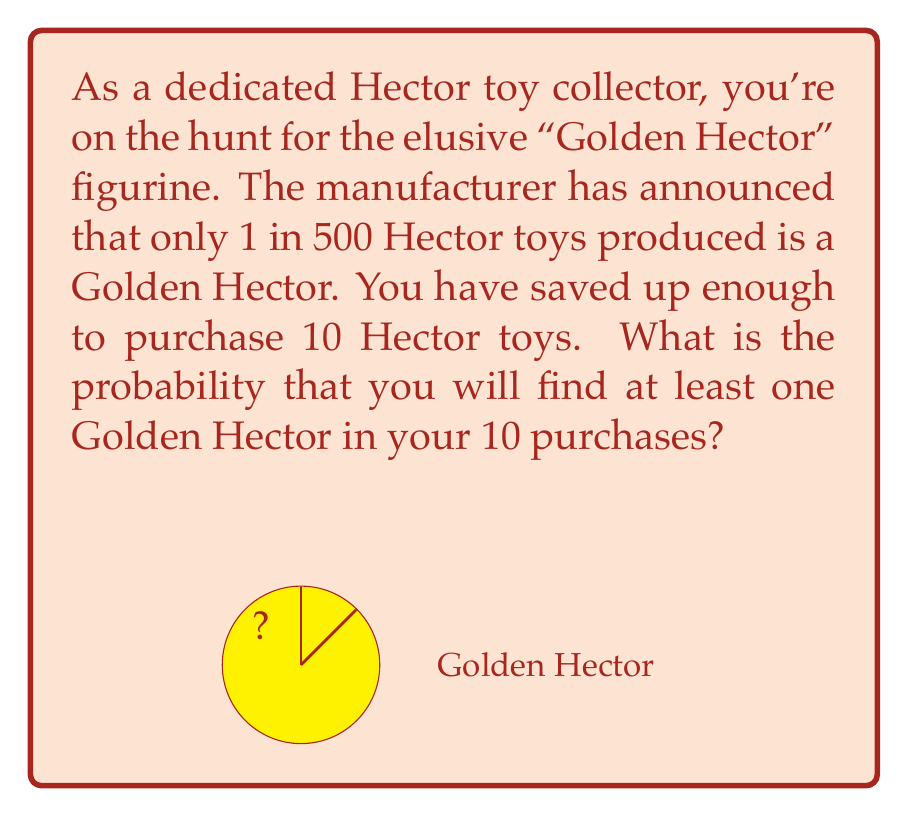Show me your answer to this math problem. Let's approach this step-by-step:

1) First, let's calculate the probability of not getting a Golden Hector in a single purchase:
   $$P(\text{not Golden}) = 1 - \frac{1}{500} = \frac{499}{500} = 0.998$$

2) Now, we need to find the probability of not getting a Golden Hector in all 10 purchases:
   $$P(\text{no Golden in 10}) = \left(\frac{499}{500}\right)^{10}$$

3) We can calculate this:
   $$\left(\frac{499}{500}\right)^{10} \approx 0.9801$$

4) This is the probability of not getting any Golden Hector. But we want the probability of getting at least one. This is the complement of not getting any:

   $$P(\text{at least one Golden}) = 1 - P(\text{no Golden in 10})$$

5) Substituting our calculated value:
   $$P(\text{at least one Golden}) = 1 - 0.9801 = 0.0199$$

6) Converting to a percentage:
   $$0.0199 \times 100\% = 1.99\%$$

Therefore, the probability of finding at least one Golden Hector in 10 purchases is approximately 1.99%.
Answer: 1.99% 